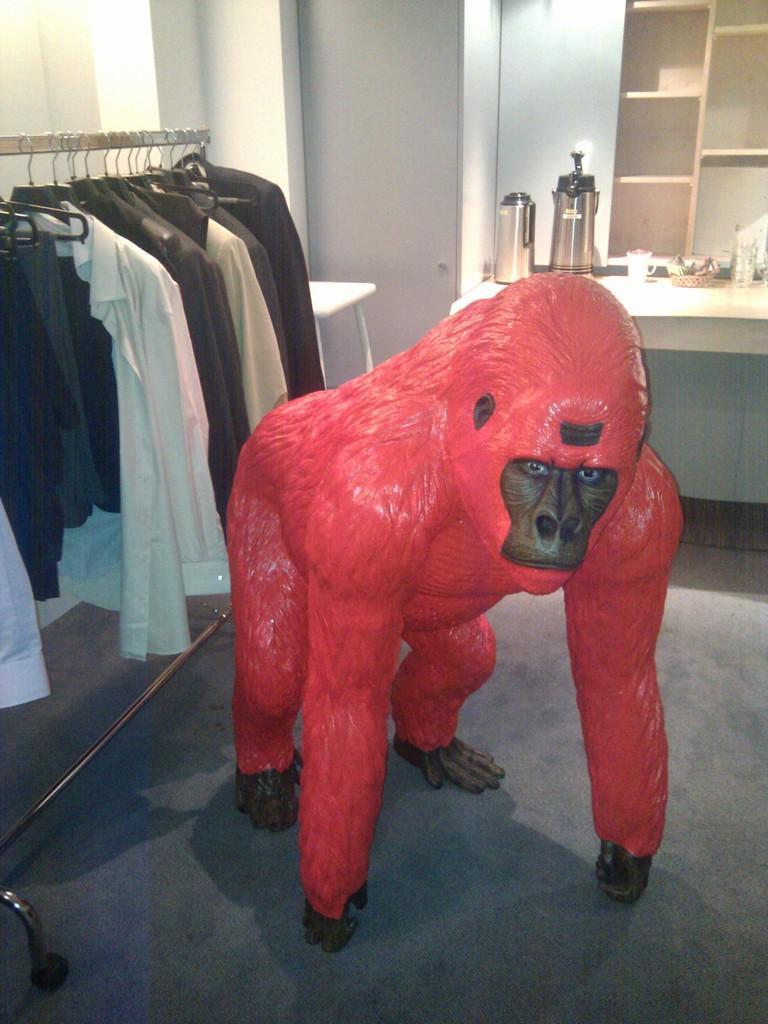Describe this image in one or two sentences. In this image there is a statue of the chimpanzee in the middle. On the left side there are clothes which are hanged to the pole. In the background there is a desk on which there are jars and cups. 